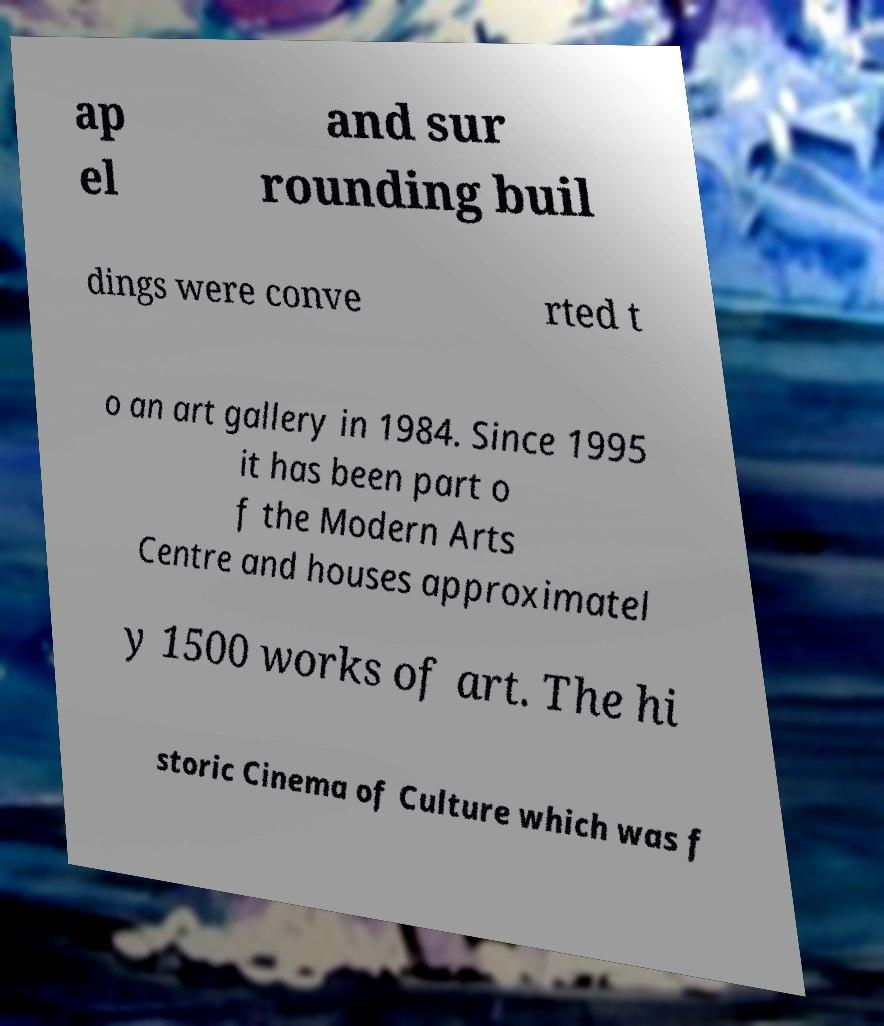Can you accurately transcribe the text from the provided image for me? ap el and sur rounding buil dings were conve rted t o an art gallery in 1984. Since 1995 it has been part o f the Modern Arts Centre and houses approximatel y 1500 works of art. The hi storic Cinema of Culture which was f 